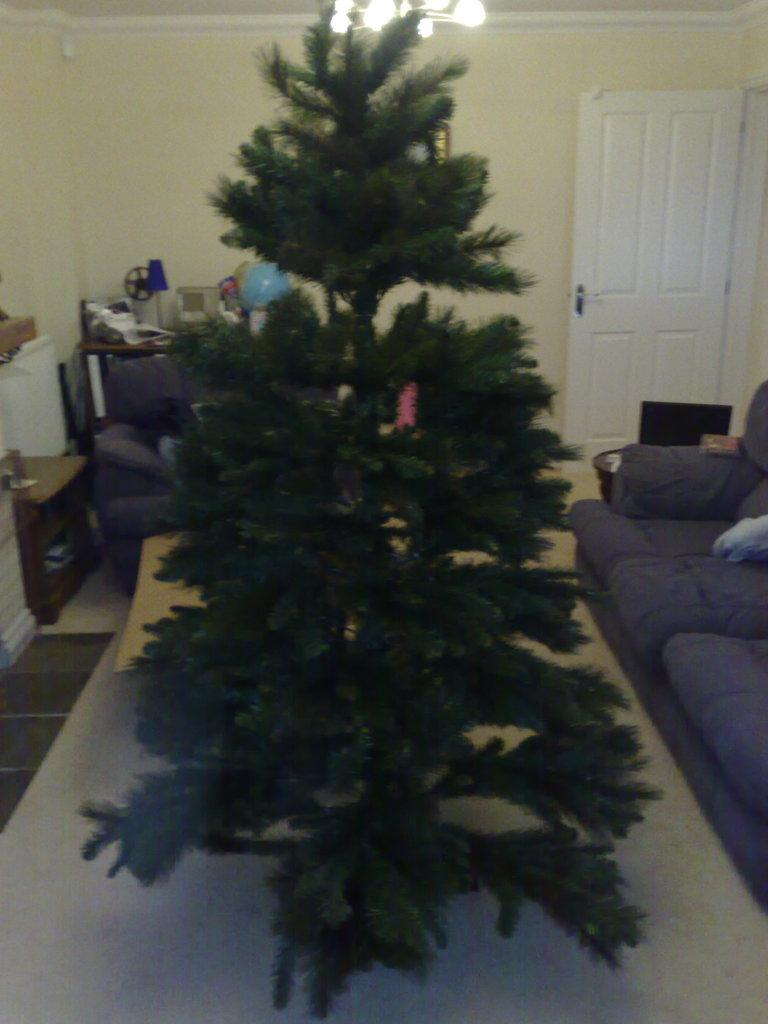What is located at the front of the scene in the image? There is a tree in front of the scene. What can be seen in the background of the image? There is a sofa set, various unspecified things, a door, and a wall in the background. Are there any light sources visible in the image? Yes, there are lights visible at the top of the image. What type of grip does the tree have on the sofa set in the image? There is no interaction between the tree and the sofa set in the image; they are separate elements in the scene. 